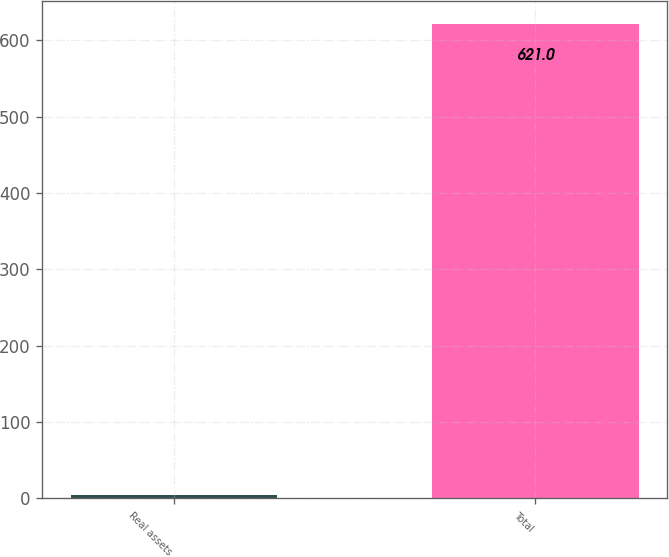Convert chart to OTSL. <chart><loc_0><loc_0><loc_500><loc_500><bar_chart><fcel>Real assets<fcel>Total<nl><fcel>4<fcel>621<nl></chart> 